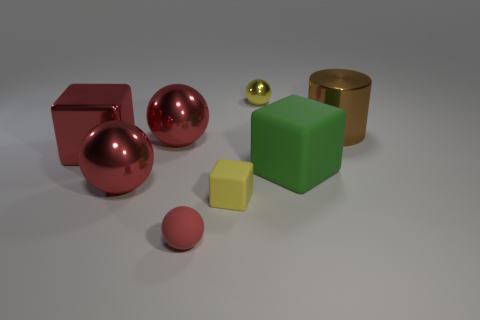How many red balls must be subtracted to get 2 red balls? 1 Subtract all green rubber blocks. How many blocks are left? 2 Add 2 yellow balls. How many objects exist? 10 Subtract all red spheres. How many spheres are left? 1 Add 6 red metal balls. How many red metal balls are left? 8 Add 3 yellow rubber blocks. How many yellow rubber blocks exist? 4 Subtract 3 red balls. How many objects are left? 5 Subtract all cylinders. How many objects are left? 7 Subtract 1 spheres. How many spheres are left? 3 Subtract all yellow cylinders. Subtract all brown blocks. How many cylinders are left? 1 